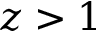Convert formula to latex. <formula><loc_0><loc_0><loc_500><loc_500>z > 1</formula> 